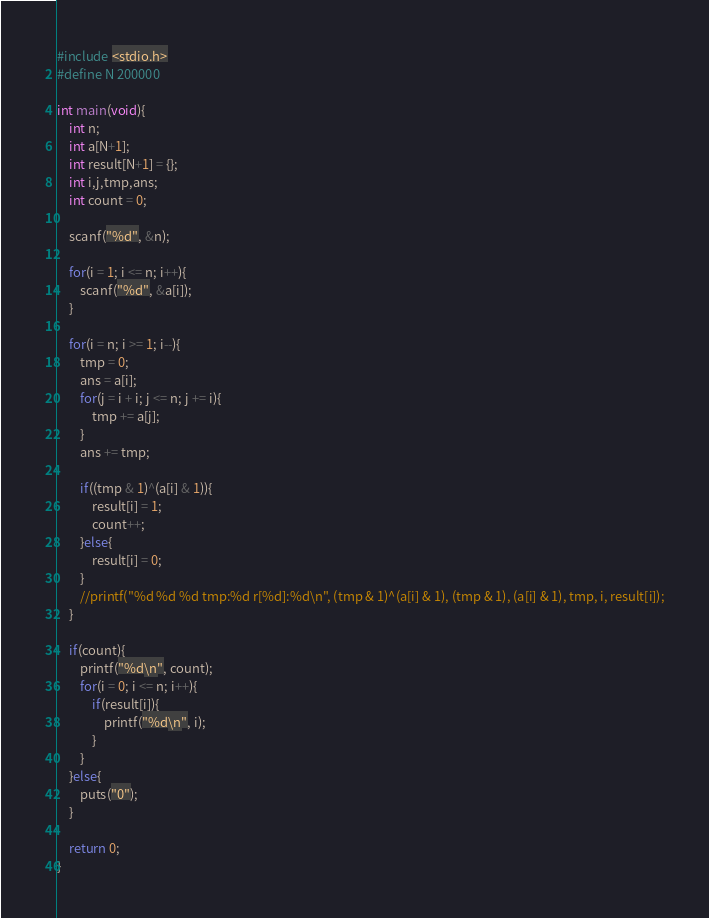Convert code to text. <code><loc_0><loc_0><loc_500><loc_500><_C_>#include <stdio.h>
#define N 200000

int main(void){
    int n;
    int a[N+1];
    int result[N+1] = {};
    int i,j,tmp,ans;
    int count = 0;
    
    scanf("%d", &n);
    
    for(i = 1; i <= n; i++){
        scanf("%d", &a[i]);
    }
    
    for(i = n; i >= 1; i--){
        tmp = 0;
        ans = a[i];
        for(j = i + i; j <= n; j += i){
            tmp += a[j];
        }
        ans += tmp;
        
        if((tmp & 1)^(a[i] & 1)){
            result[i] = 1;
            count++;
        }else{
            result[i] = 0;
        }
        //printf("%d %d %d tmp:%d r[%d]:%d\n", (tmp & 1)^(a[i] & 1), (tmp & 1), (a[i] & 1), tmp, i, result[i]);
    }
    
    if(count){
        printf("%d\n", count);
        for(i = 0; i <= n; i++){
            if(result[i]){
                printf("%d\n", i);
            }
        }
    }else{
        puts("0");
    }
    
    return 0;
}</code> 